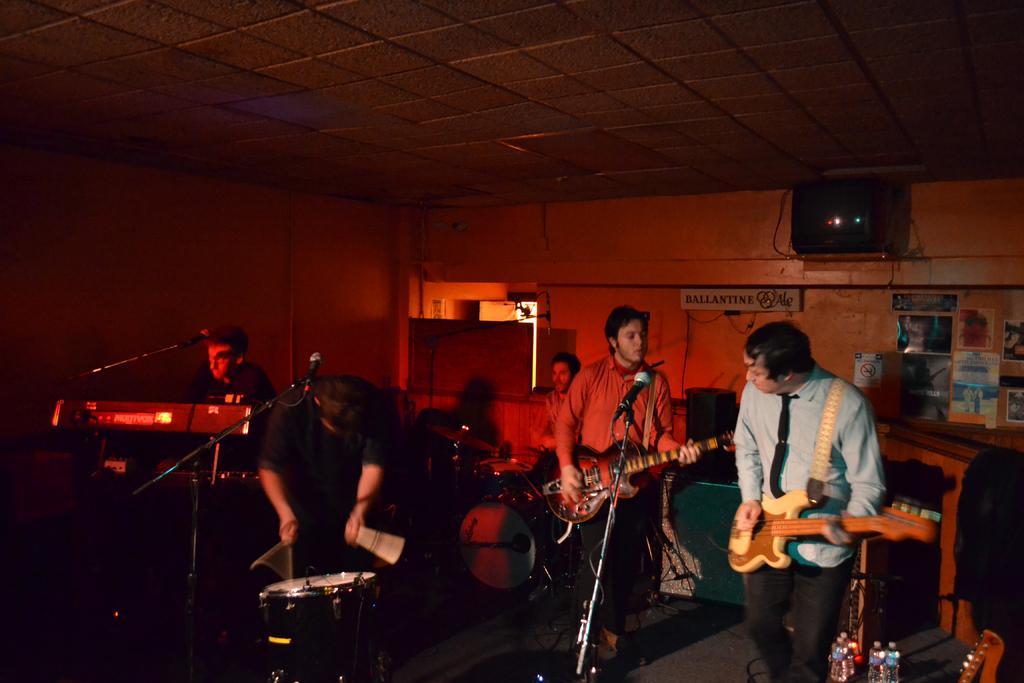How would you summarize this image in a sentence or two? The image is inside the room. In the image there are five people playing their musical instruments, on right side their is a red color shirt man holding a guitar and playing it in front of a microphone and we can also see table,shelf and a wall,television and roof is on top. 